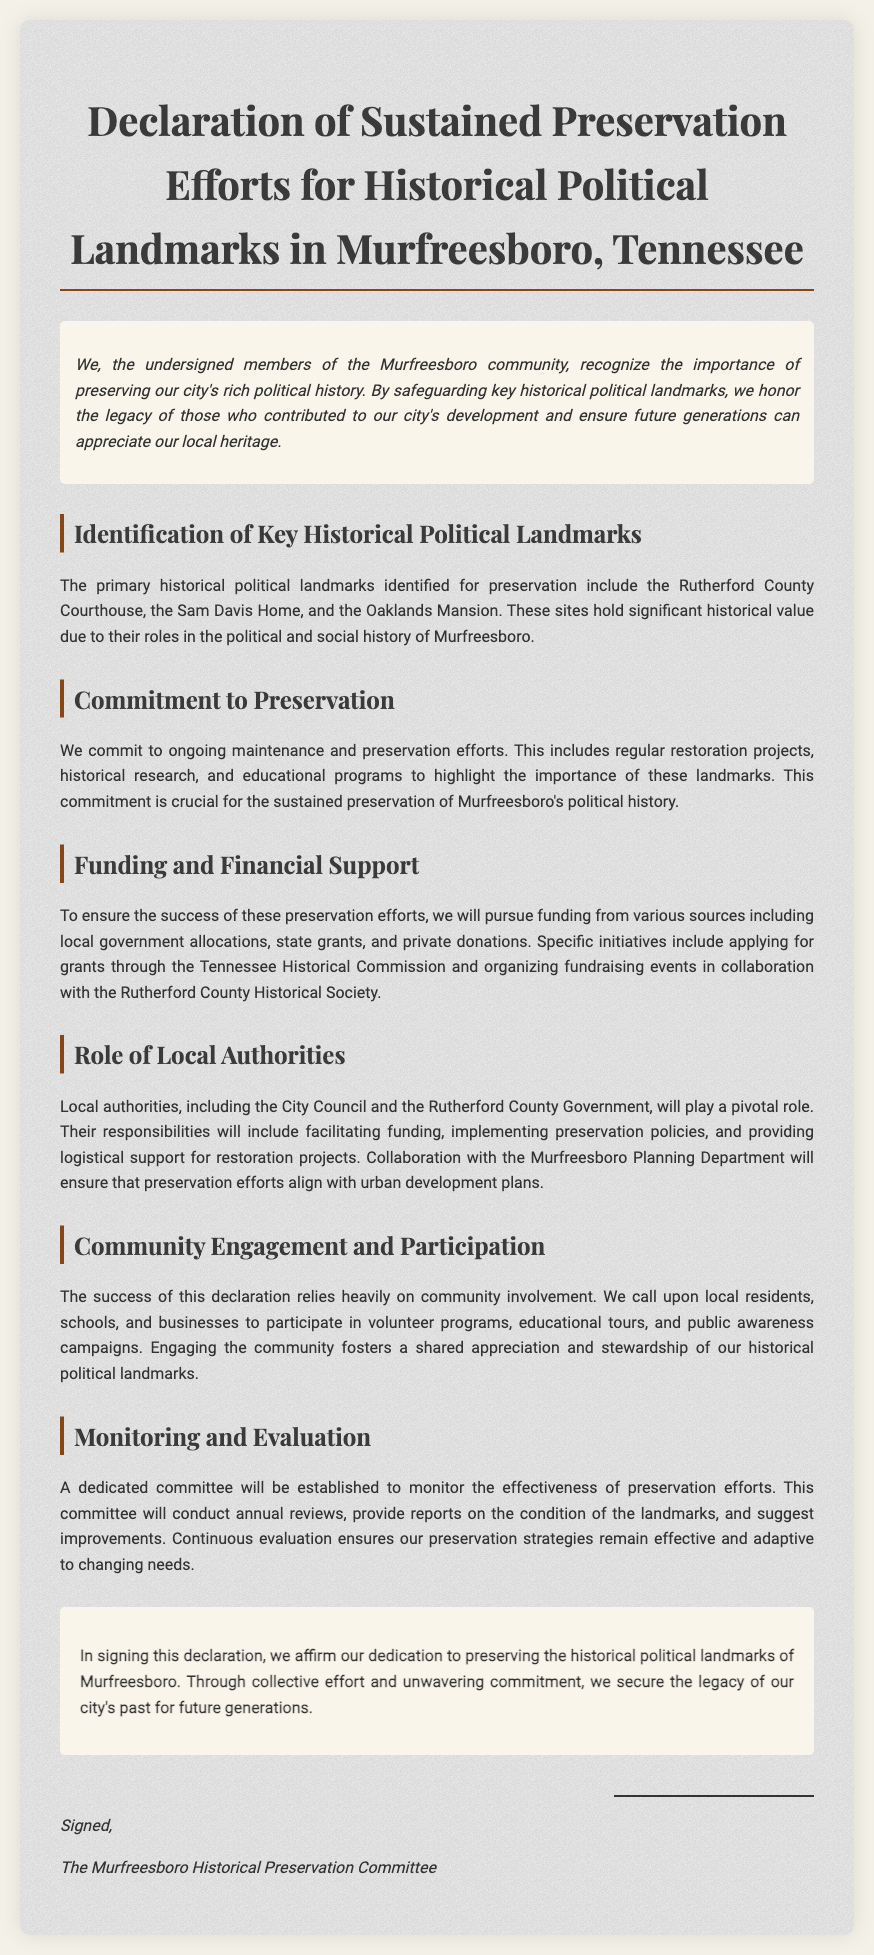what are the key historical political landmarks mentioned? The key historical political landmarks listed in the document are the Rutherford County Courthouse, the Sam Davis Home, and the Oaklands Mansion.
Answer: Rutherford County Courthouse, Sam Davis Home, Oaklands Mansion what is the main focus of the commitment? The commitment focuses on ongoing maintenance and preservation efforts, including regular restoration projects, historical research, and educational programs.
Answer: Ongoing maintenance and preservation efforts which organizations will be pursued for funding? The document mentions the Tennessee Historical Commission and the Rutherford County Historical Society as organizations for funding initiatives.
Answer: Tennessee Historical Commission, Rutherford County Historical Society who will play a pivotal role in preservation efforts? The role of local authorities, specifically the City Council and the Rutherford County Government, is highlighted as pivotal.
Answer: City Council and Rutherford County Government what will the dedicated committee do? The dedicated committee will monitor the effectiveness of preservation efforts, conduct annual reviews, and provide reports on the condition of the landmarks.
Answer: Monitor effectiveness of preservation efforts how will community engagement be fostered? Community engagement will be encouraged through volunteer programs, educational tours, and public awareness campaigns.
Answer: Volunteer programs, educational tours, public awareness campaigns what is the purpose of the declaration? The purpose of the declaration is to affirm the dedication to preserving the historical political landmarks of Murfreesboro.
Answer: Affirm dedication to preserving historical landmarks who signed the declaration? The declaration is signed by the Murfreesboro Historical Preservation Committee.
Answer: Murfreesboro Historical Preservation Committee 